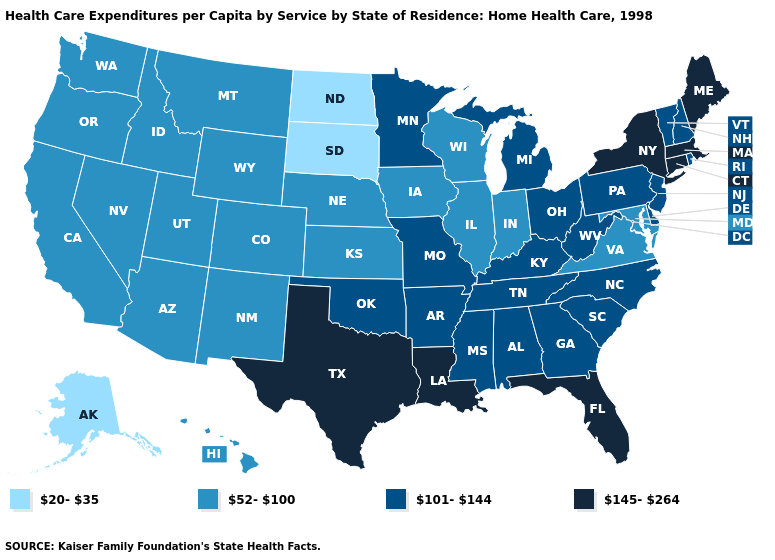Does Texas have the lowest value in the South?
Quick response, please. No. What is the lowest value in states that border Kansas?
Answer briefly. 52-100. What is the value of Massachusetts?
Be succinct. 145-264. Name the states that have a value in the range 145-264?
Be succinct. Connecticut, Florida, Louisiana, Maine, Massachusetts, New York, Texas. Which states hav the highest value in the West?
Keep it brief. Arizona, California, Colorado, Hawaii, Idaho, Montana, Nevada, New Mexico, Oregon, Utah, Washington, Wyoming. What is the lowest value in the MidWest?
Answer briefly. 20-35. Which states have the highest value in the USA?
Write a very short answer. Connecticut, Florida, Louisiana, Maine, Massachusetts, New York, Texas. Name the states that have a value in the range 52-100?
Be succinct. Arizona, California, Colorado, Hawaii, Idaho, Illinois, Indiana, Iowa, Kansas, Maryland, Montana, Nebraska, Nevada, New Mexico, Oregon, Utah, Virginia, Washington, Wisconsin, Wyoming. Does Washington have the same value as Nebraska?
Give a very brief answer. Yes. Which states hav the highest value in the West?
Quick response, please. Arizona, California, Colorado, Hawaii, Idaho, Montana, Nevada, New Mexico, Oregon, Utah, Washington, Wyoming. Does Alaska have the highest value in the West?
Keep it brief. No. Among the states that border California , which have the lowest value?
Concise answer only. Arizona, Nevada, Oregon. What is the lowest value in the USA?
Quick response, please. 20-35. What is the value of Oklahoma?
Give a very brief answer. 101-144. What is the value of Nevada?
Be succinct. 52-100. 